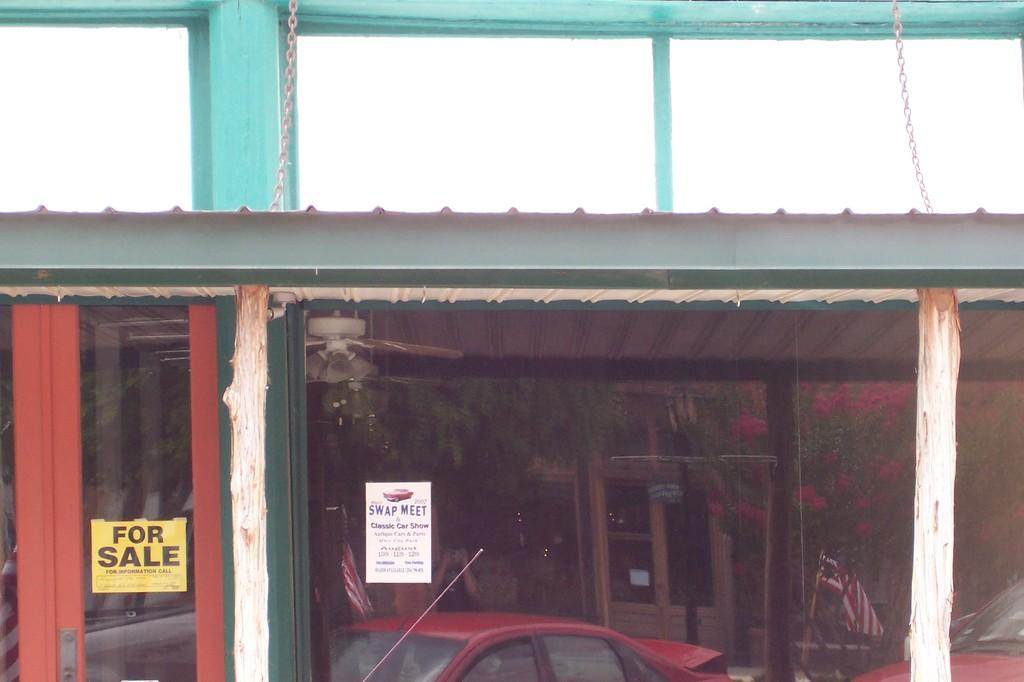What type of vehicles can be seen in the image? There are cars in the image. What other objects are present in the image besides cars? There are flags, posters, pillars, trees, and chains in the image. What might the flags represent in the image? The flags could represent a country, organization, or event. How many types of objects can be seen in the image? There are six types of objects present in the image: cars, flags, posters, pillars, trees, and chains. Which team is participating in the competition depicted in the image? There is no competition or team present in the image. What type of sponge can be seen soaking up water in the image? There is no sponge present in the image. 